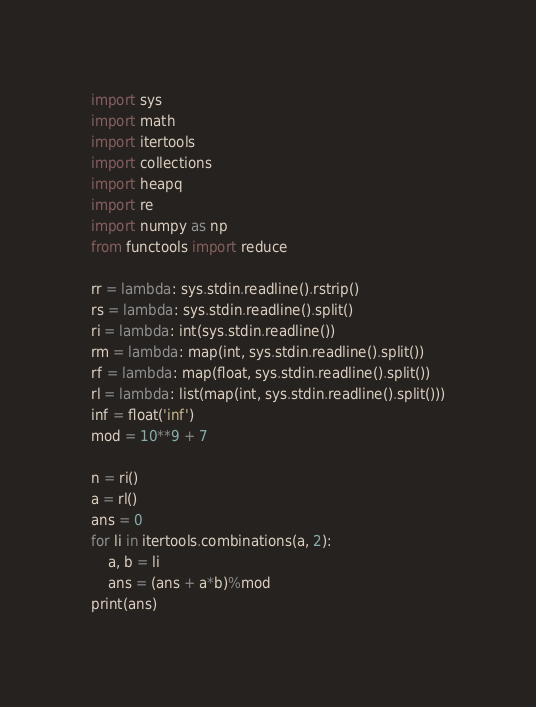Convert code to text. <code><loc_0><loc_0><loc_500><loc_500><_Python_>import sys
import math
import itertools
import collections
import heapq
import re
import numpy as np
from functools import reduce

rr = lambda: sys.stdin.readline().rstrip()
rs = lambda: sys.stdin.readline().split()
ri = lambda: int(sys.stdin.readline())
rm = lambda: map(int, sys.stdin.readline().split())
rf = lambda: map(float, sys.stdin.readline().split())
rl = lambda: list(map(int, sys.stdin.readline().split()))
inf = float('inf')
mod = 10**9 + 7

n = ri()
a = rl()
ans = 0
for li in itertools.combinations(a, 2):
    a, b = li
    ans = (ans + a*b)%mod
print(ans)










</code> 